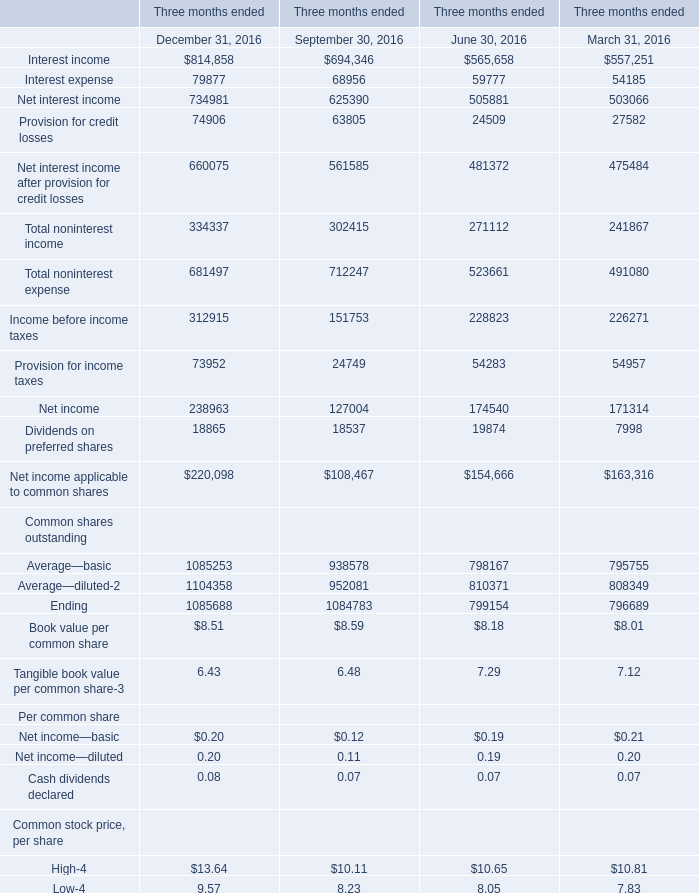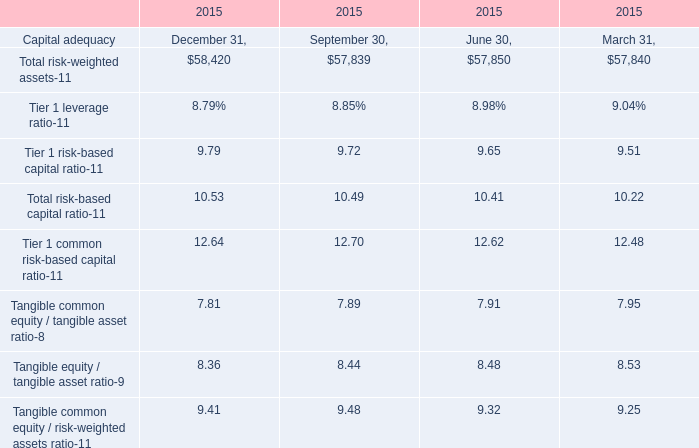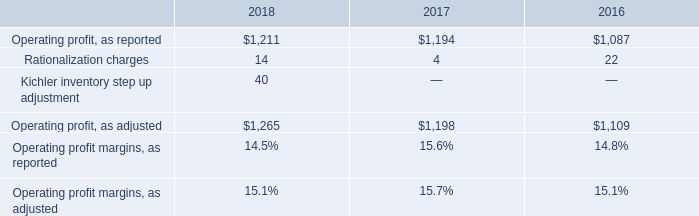What is the sum of Interest income in the range of 690000 and 900000 in 2016? 
Computations: (814858 + 694346)
Answer: 1509204.0. 